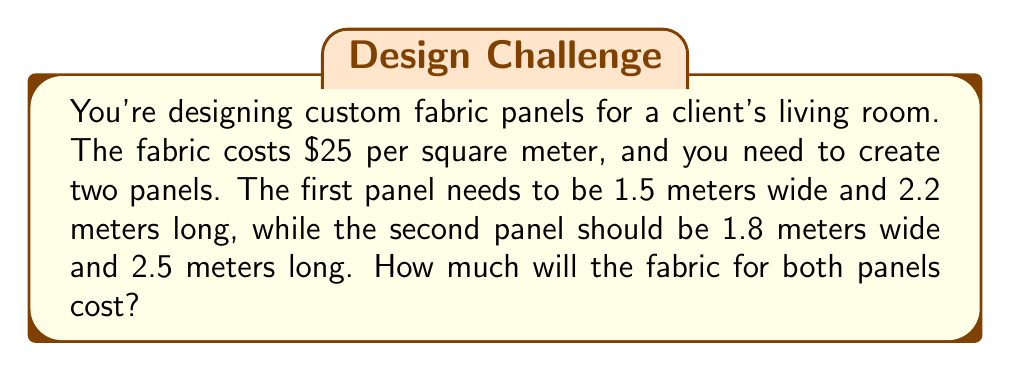Show me your answer to this math problem. Let's approach this step-by-step:

1. Calculate the area of the first panel:
   $A_1 = 1.5 \text{ m} \times 2.2 \text{ m} = 3.3 \text{ m}^2$

2. Calculate the area of the second panel:
   $A_2 = 1.8 \text{ m} \times 2.5 \text{ m} = 4.5 \text{ m}^2$

3. Calculate the total area of fabric needed:
   $A_{\text{total}} = A_1 + A_2 = 3.3 \text{ m}^2 + 4.5 \text{ m}^2 = 7.8 \text{ m}^2$

4. Set up a linear equation to calculate the cost:
   Let $C$ be the total cost.
   $C = 25 \times A_{\text{total}}$

5. Plug in the total area:
   $C = 25 \times 7.8 = 195$

Therefore, the fabric for both panels will cost $195.
Answer: $195 